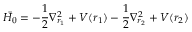Convert formula to latex. <formula><loc_0><loc_0><loc_500><loc_500>{ \bar { H _ { 0 } } } = - { \frac { 1 } { 2 } } \nabla _ { r _ { 1 } } ^ { 2 } + V ( r _ { 1 } ) - { \frac { 1 } { 2 } } \nabla _ { r _ { 2 } } ^ { 2 } + V ( r _ { 2 } )</formula> 